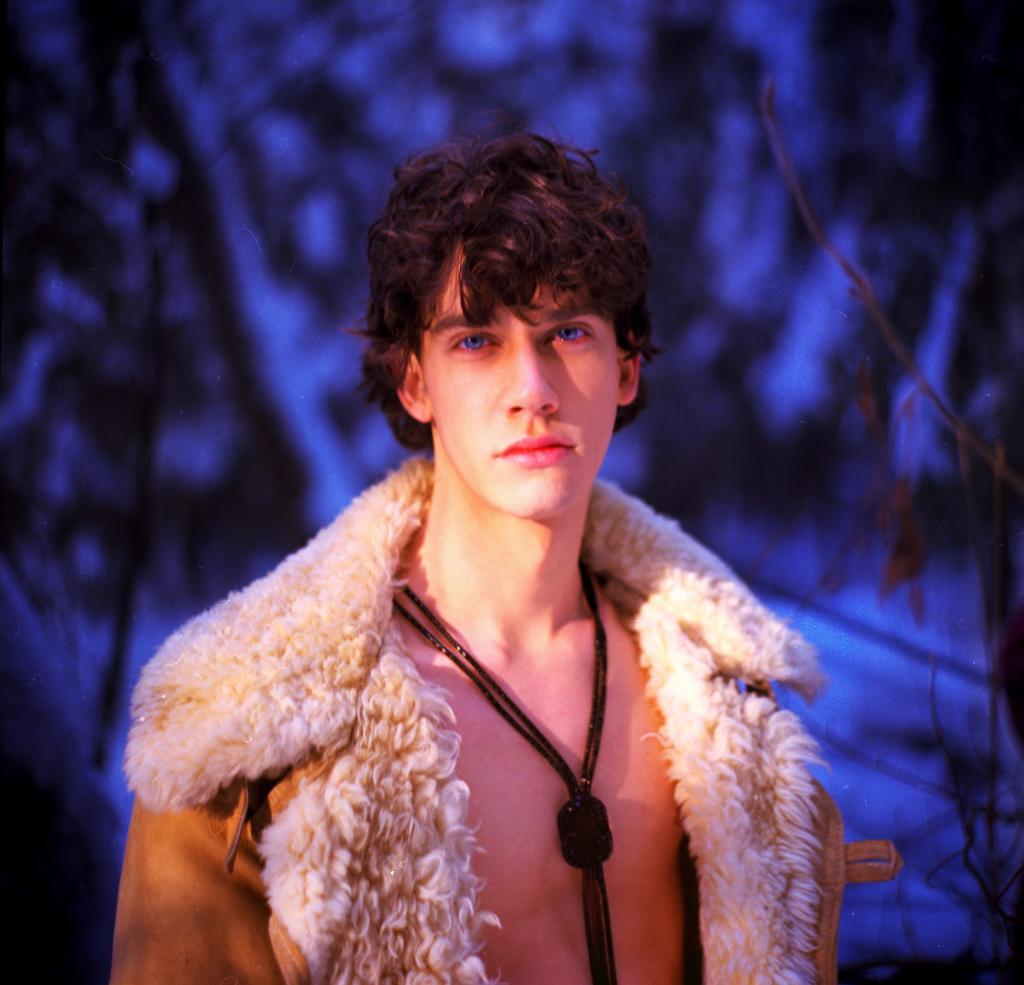Please provide a concise description of this image. In this image I can see the person with the dress. In the background I can see the trees and I can see the blue and black background. 